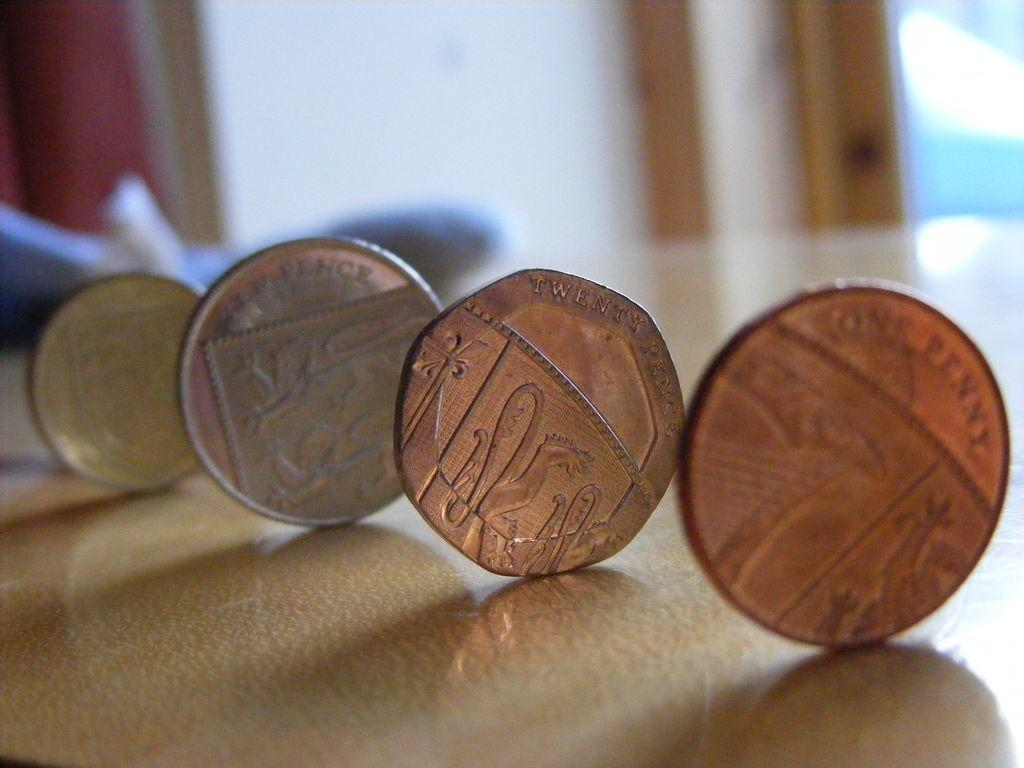<image>
Share a concise interpretation of the image provided. four copper pence coins are lined up on their edges 